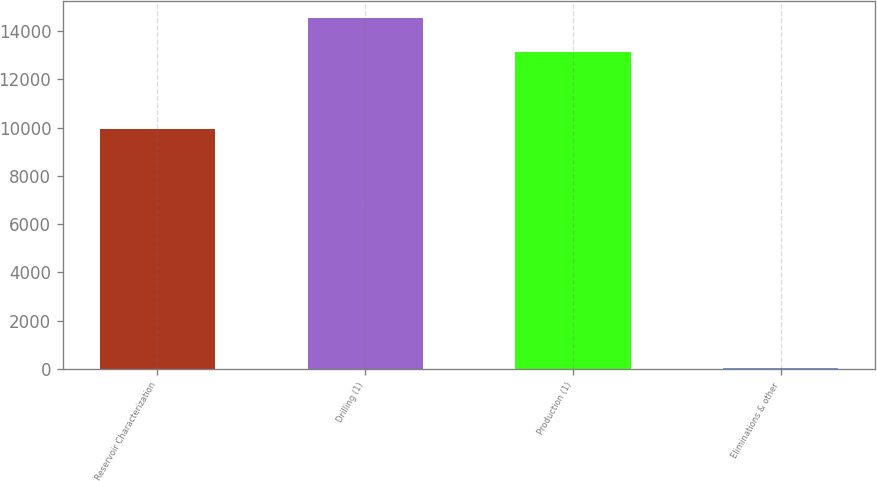Convert chart to OTSL. <chart><loc_0><loc_0><loc_500><loc_500><bar_chart><fcel>Reservoir Characterization<fcel>Drilling (1)<fcel>Production (1)<fcel>Eliminations & other<nl><fcel>9929<fcel>14518.6<fcel>13136<fcel>34<nl></chart> 